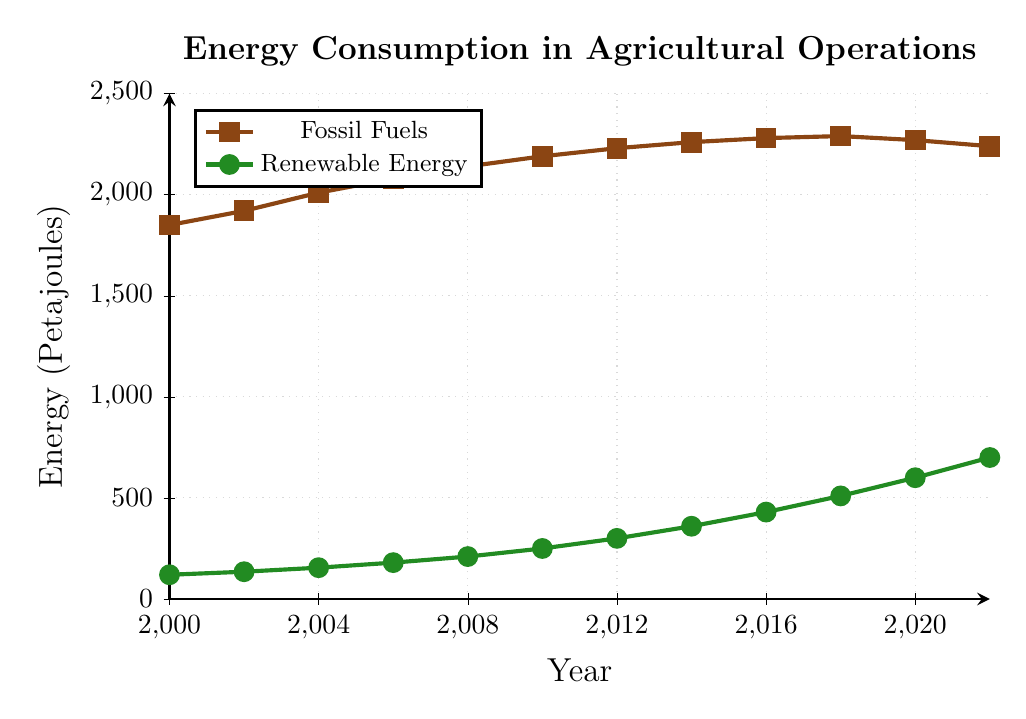What is the trend of fossil fuel consumption over the years? The fossil fuel consumption starts at 1850 Petajoules in 2000 and generally increases until 2018 at 2290 Petajoules and then slightly decreases to 2240 Petajoules in 2022.
Answer: General increase with a slight decrease towards the end How does renewable energy consumption in 2010 compare to 2022? In 2010, renewable energy consumption is at 250 Petajoules, whereas in 2022, it increases to 700 Petajoules. Therefore, it has significantly increased over these years.
Answer: It has significantly increased What is the difference in energy consumption from fossil fuels between 2000 and 2022? The fossil fuel consumption in 2000 is 1850 Petajoules and in 2022 it is 2240 Petajoules. The difference can be calculated as 2240 - 1850 = 390 Petajoules.
Answer: 390 Petajoules Which year shows the highest consumption of renewable energy? By examining the values on the graph, the highest renewable energy consumption is in 2022, reaching 700 Petajoules.
Answer: 2022 What is the average consumption of renewable energy from 2000 to 2022? Sum the renewable energy values (120 + 135 + 155 + 180 + 210 + 250 + 300 + 360 + 430 + 510 + 600 + 700 = 3950 Petajoules) and divide by the number of years (3950 / 12 = 329.17).
Answer: 329.17 Petajoules How did the consumption of fossil fuels change between 2014 to 2018? In 2014, the consumption is 2260 Petajoules, and in 2018, it is 2290 Petajoules. The change is 2290 - 2260 = 30 Petajoules increase.
Answer: Increased by 30 Petajoules What is the total energy consumption from both sources in 2022? In 2022, fossil fuels are 2240 Petajoules and renewable energy is 700 Petajoules. The total consumption is 2240 + 700 = 2940 Petajoules.
Answer: 2940 Petajoules By how much did renewable energy consumption rise from 2000 to 2020? Renewable energy consumption in 2000 is 120 Petajoules and in 2020 it is 600 Petajoules. The difference is 600 - 120 = 480 Petajoules.
Answer: 480 Petajoules In which year did renewable energy consumption surpass 400 Petajoules? By examining the graph, renewable energy consumption surpasses 400 Petajoules in 2016 with a value of 430 Petajoules.
Answer: 2016 